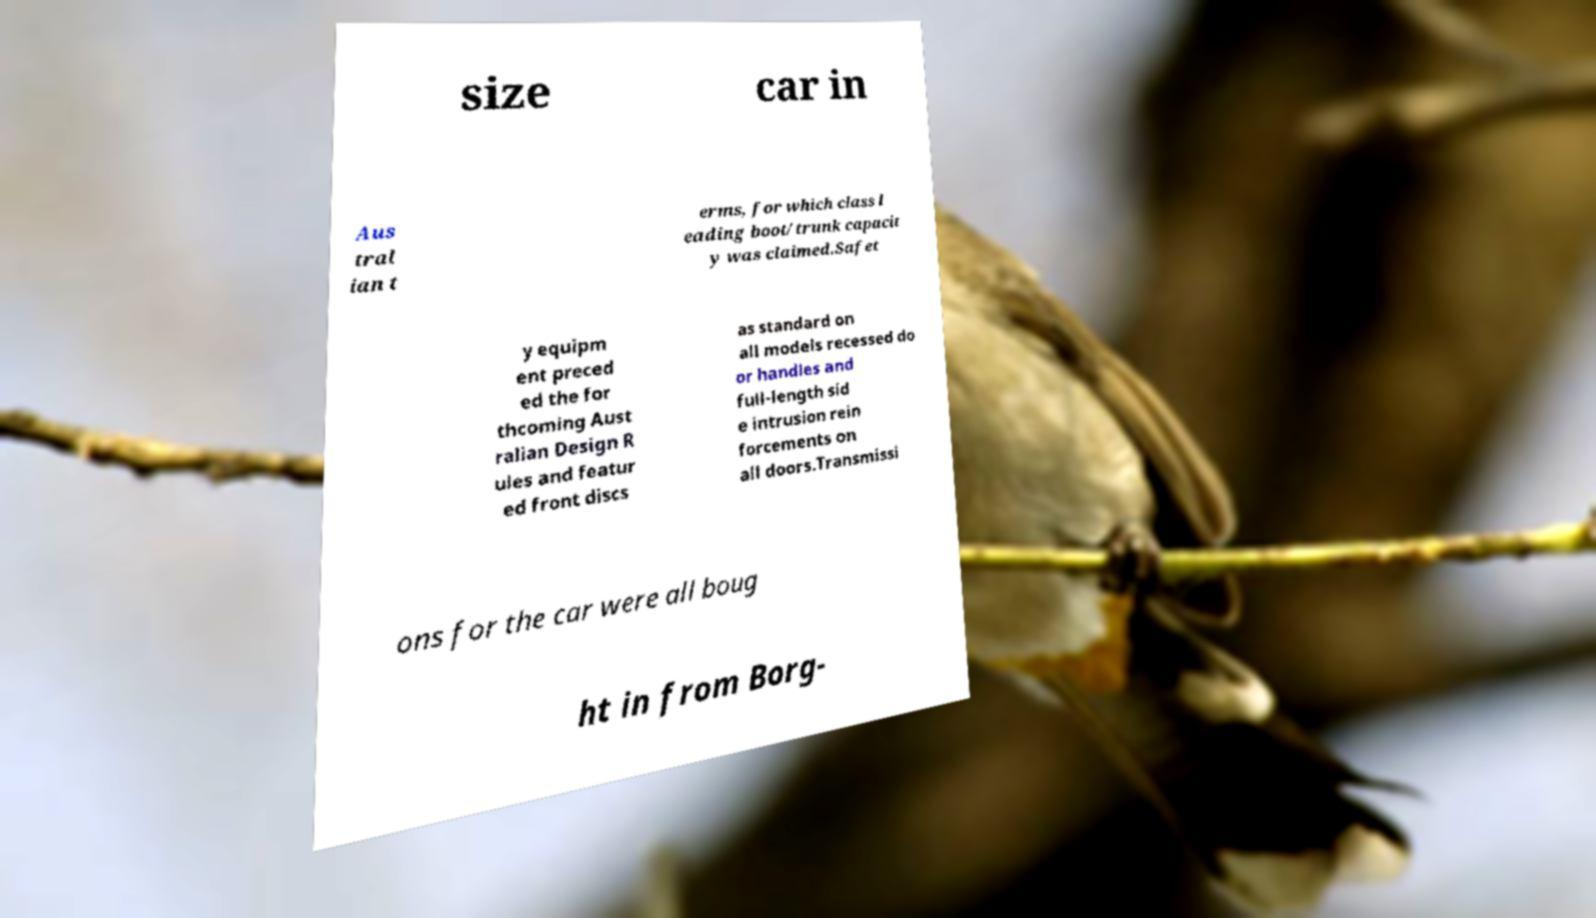There's text embedded in this image that I need extracted. Can you transcribe it verbatim? size car in Aus tral ian t erms, for which class l eading boot/trunk capacit y was claimed.Safet y equipm ent preced ed the for thcoming Aust ralian Design R ules and featur ed front discs as standard on all models recessed do or handles and full-length sid e intrusion rein forcements on all doors.Transmissi ons for the car were all boug ht in from Borg- 